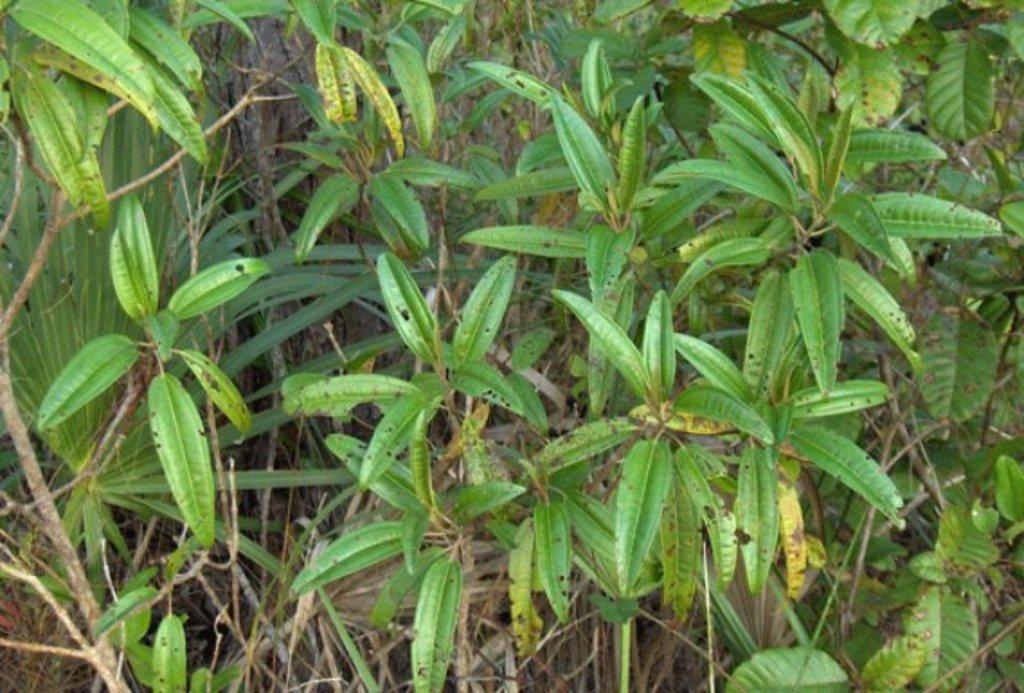What type of living organisms can be seen in the image? Plants can be seen in the image. What colors are present on the plants in the image? The plants have green and brown colors, and some leaves are yellow in color. Where are the plants located in the image? The plants are on the ground. What type of lettuce can be seen growing in the mist in the image? There is no lettuce or mist present in the image; it features plants with green, brown, and yellow leaves on the ground. 